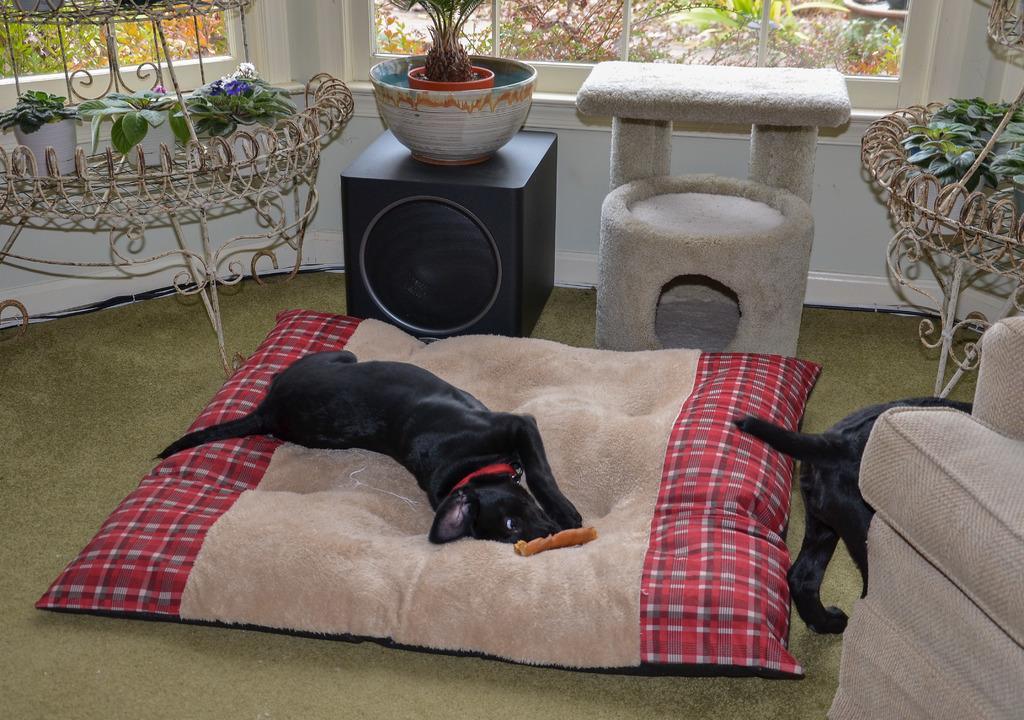Describe this image in one or two sentences. In this image, we can see a dog and an object on the bed. In the background, there is a sound box and we can see stands and houseplants and there is a couch and an other dog and there are windows, through the glass we can see plants and there is a chair. At the bottom, there is a floor. 